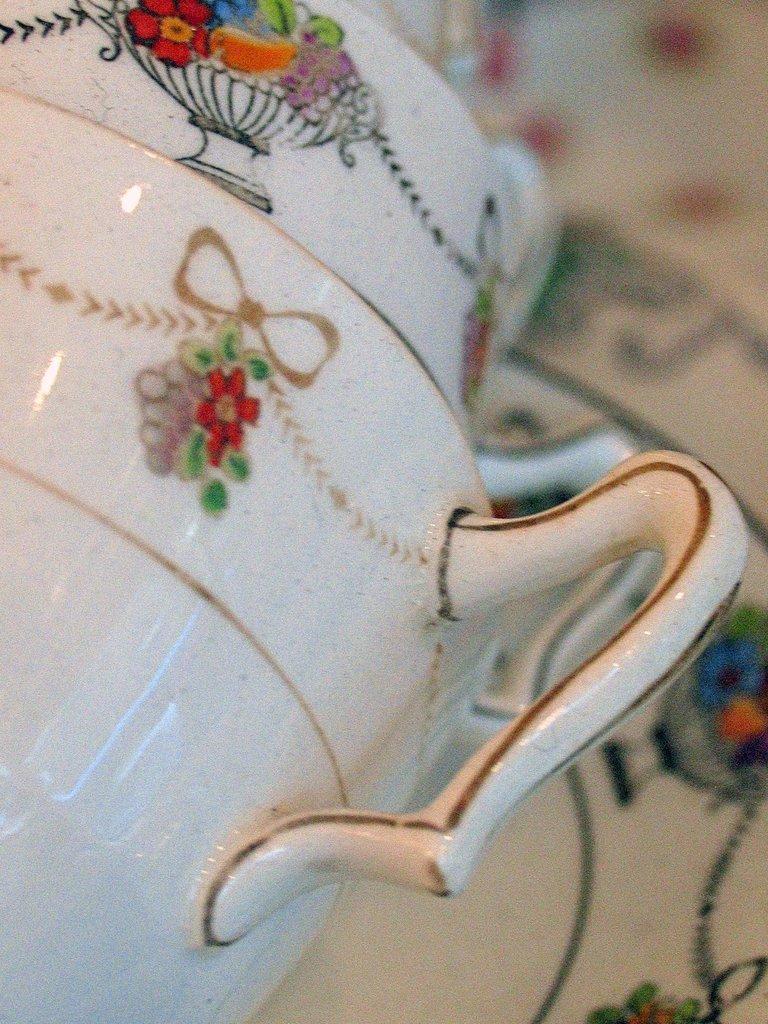Describe this image in one or two sentences. In this picture, it seems like a ceramic utensil in the foreground. 